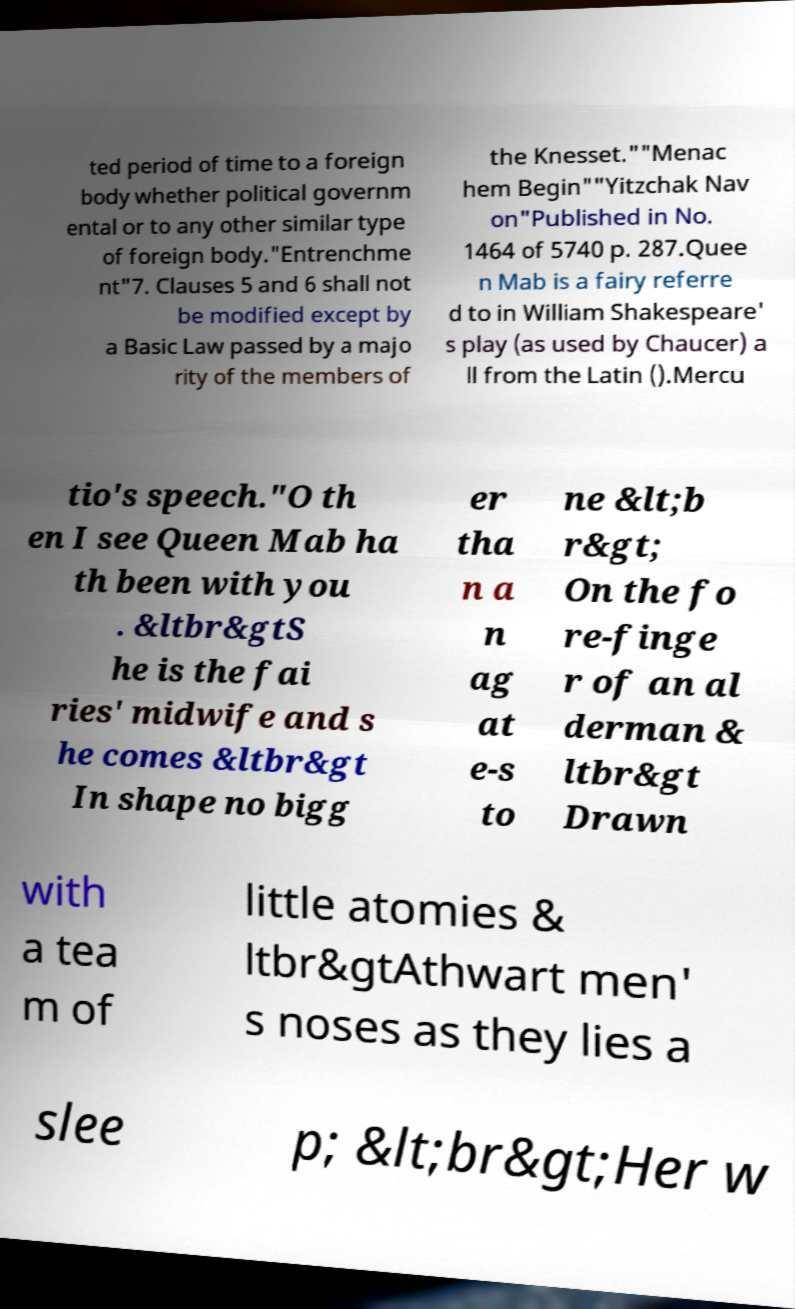There's text embedded in this image that I need extracted. Can you transcribe it verbatim? ted period of time to a foreign body whether political governm ental or to any other similar type of foreign body."Entrenchme nt"7. Clauses 5 and 6 shall not be modified except by a Basic Law passed by a majo rity of the members of the Knesset.""Menac hem Begin""Yitzchak Nav on"Published in No. 1464 of 5740 p. 287.Quee n Mab is a fairy referre d to in William Shakespeare' s play (as used by Chaucer) a ll from the Latin ().Mercu tio's speech."O th en I see Queen Mab ha th been with you . &ltbr&gtS he is the fai ries' midwife and s he comes &ltbr&gt In shape no bigg er tha n a n ag at e-s to ne &lt;b r&gt; On the fo re-finge r of an al derman & ltbr&gt Drawn with a tea m of little atomies & ltbr&gtAthwart men' s noses as they lies a slee p; &lt;br&gt;Her w 